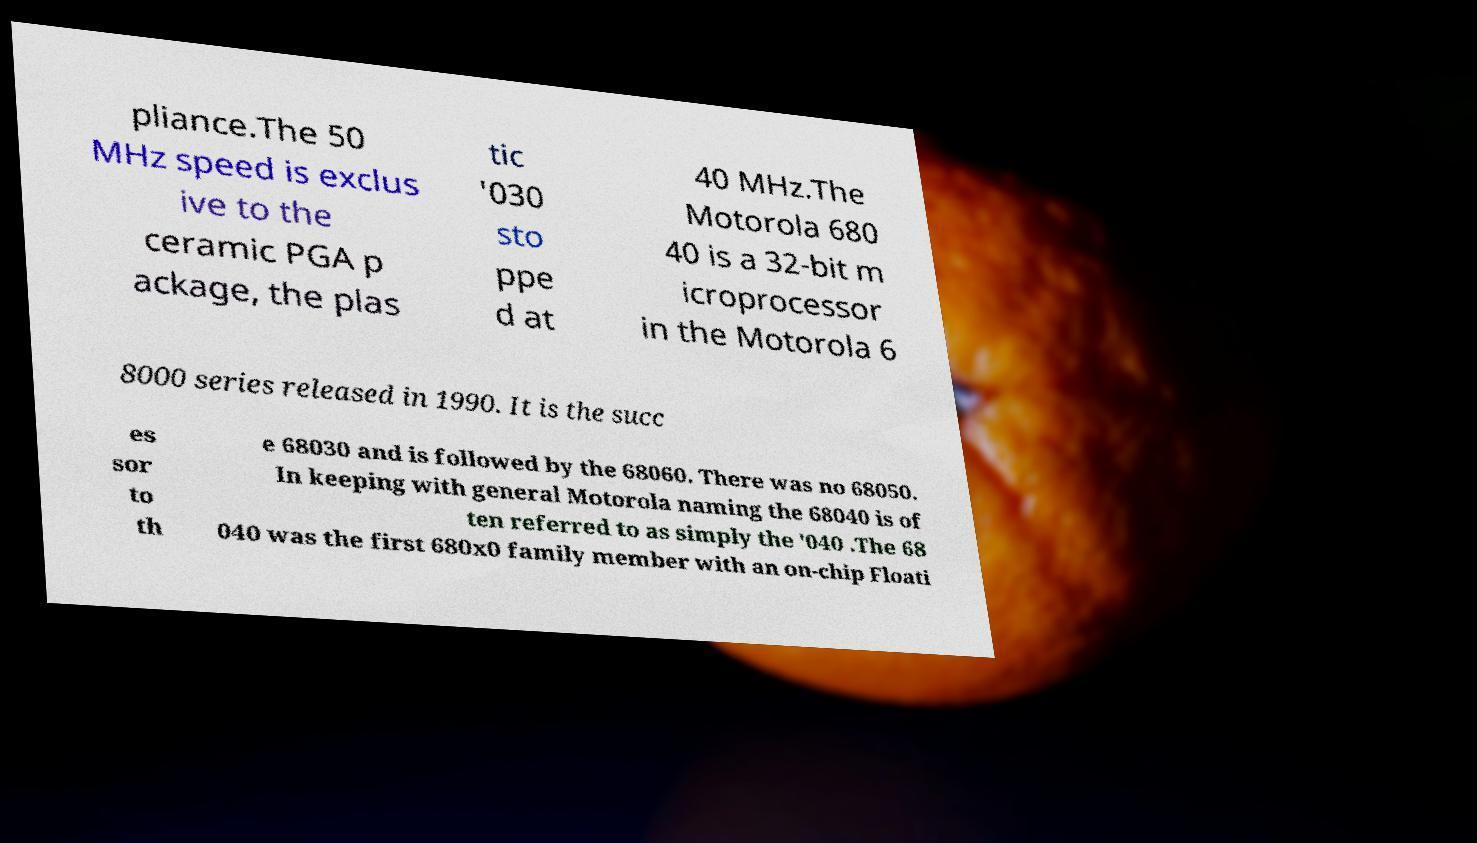Could you extract and type out the text from this image? pliance.The 50 MHz speed is exclus ive to the ceramic PGA p ackage, the plas tic '030 sto ppe d at 40 MHz.The Motorola 680 40 is a 32-bit m icroprocessor in the Motorola 6 8000 series released in 1990. It is the succ es sor to th e 68030 and is followed by the 68060. There was no 68050. In keeping with general Motorola naming the 68040 is of ten referred to as simply the '040 .The 68 040 was the first 680x0 family member with an on-chip Floati 